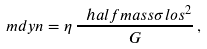Convert formula to latex. <formula><loc_0><loc_0><loc_500><loc_500>\ m d y n = \eta \, \frac { \ h a l f m a s s \sigma l o s ^ { 2 } } { G } \, ,</formula> 